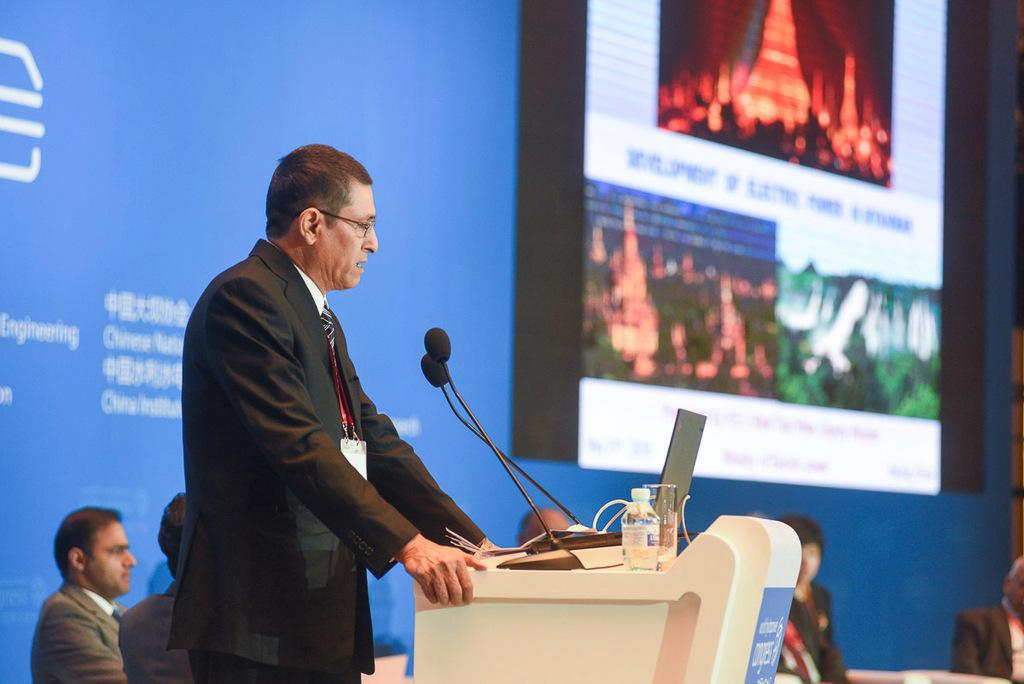What is the man in the image doing? There is a man standing in front of the podium. What object is present for the man to speak into? A microphone is present in the image. What can be seen in the background of the image? There is a projector in the background. Can you describe the other person in the image? There is a man sitting in the background. How does the man adjust the zipper on his jacket during the presentation? There is no zipper present on the man's clothing in the image, nor is there any indication that he is adjusting anything. 